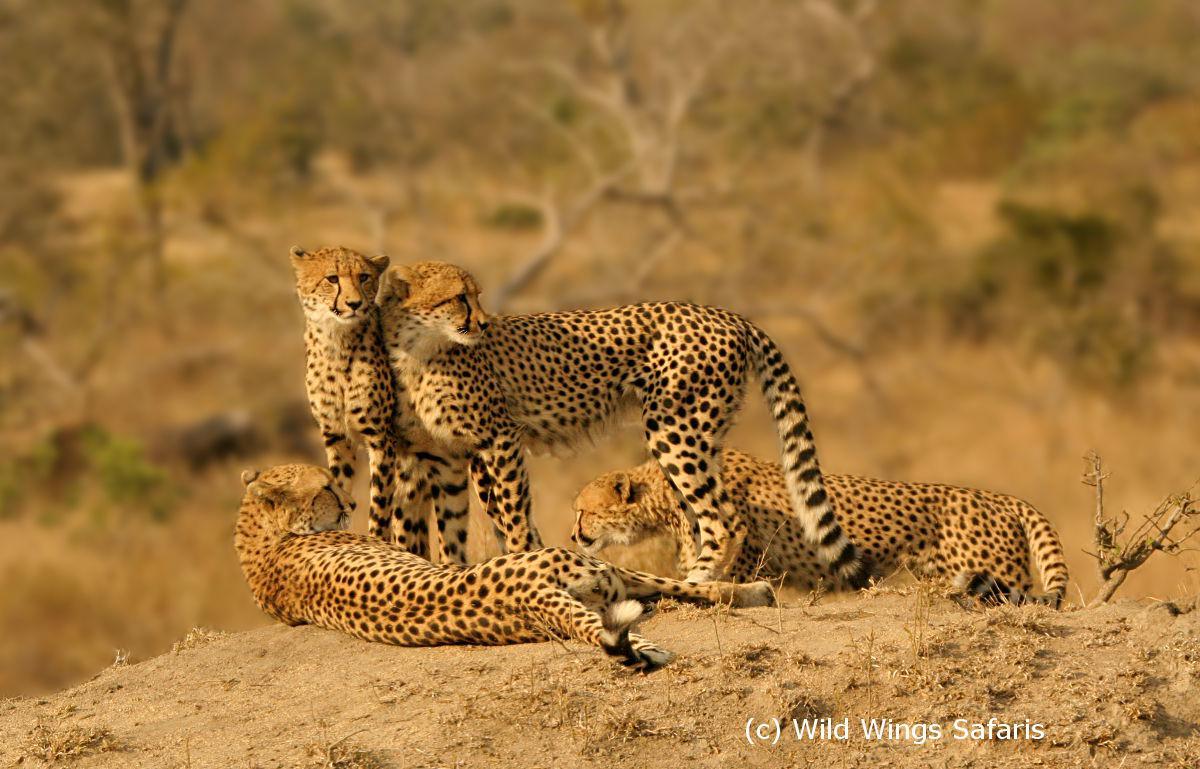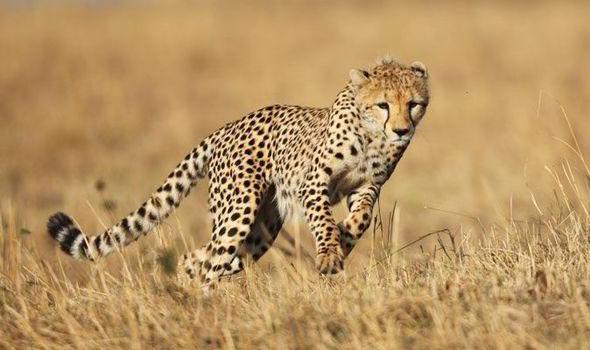The first image is the image on the left, the second image is the image on the right. Analyze the images presented: Is the assertion "You'll notice a handful of cheetah cubs in one of the images." valid? Answer yes or no. No. 